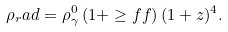Convert formula to latex. <formula><loc_0><loc_0><loc_500><loc_500>\rho _ { r } a d = \rho _ { \gamma } ^ { 0 } \left ( 1 + \geq f f \right ) ( 1 + z ) ^ { 4 } .</formula> 